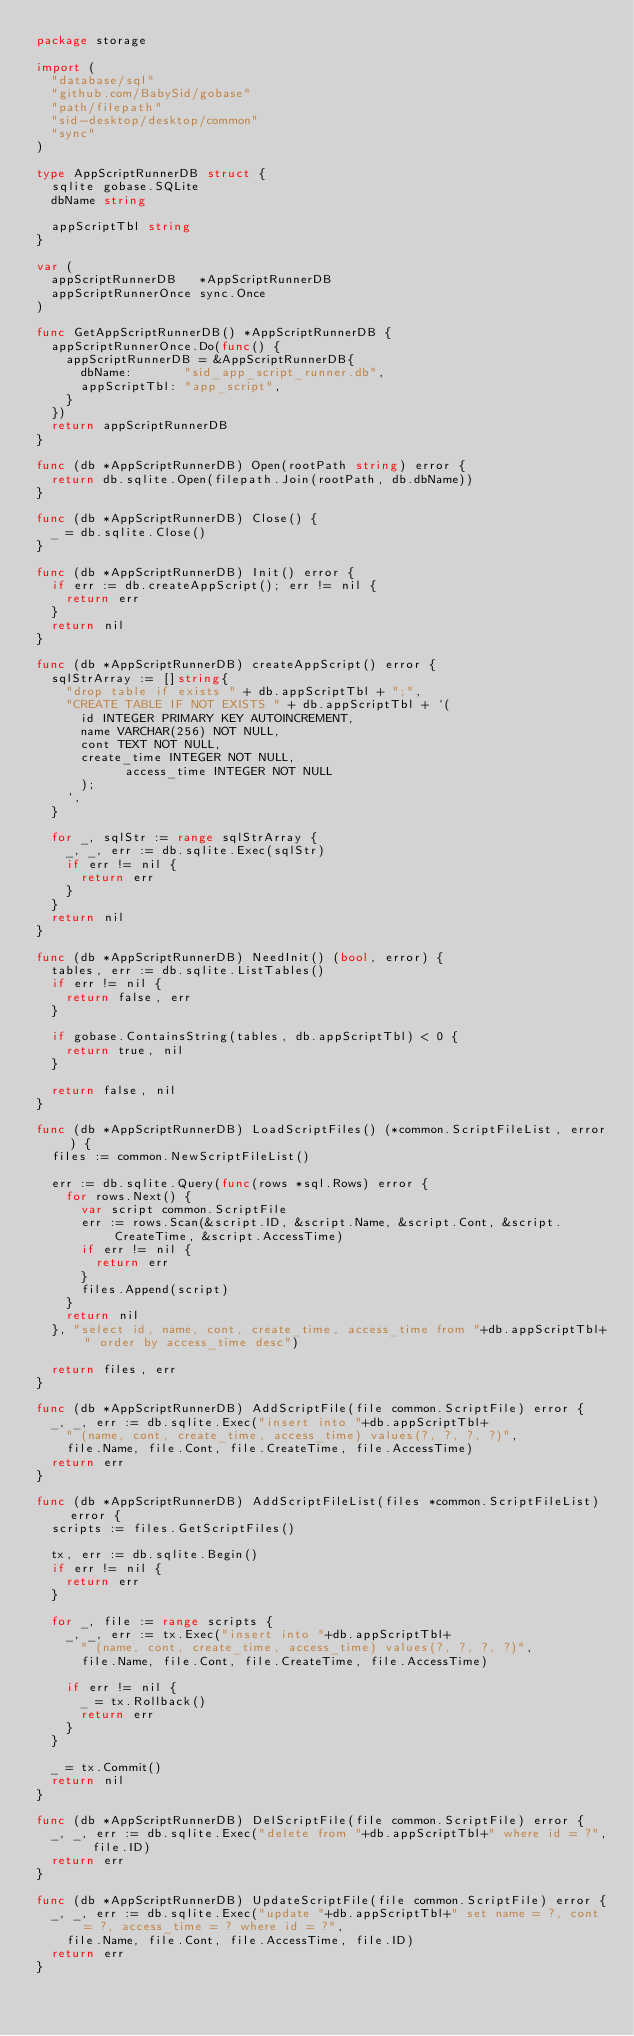<code> <loc_0><loc_0><loc_500><loc_500><_Go_>package storage

import (
	"database/sql"
	"github.com/BabySid/gobase"
	"path/filepath"
	"sid-desktop/desktop/common"
	"sync"
)

type AppScriptRunnerDB struct {
	sqlite gobase.SQLite
	dbName string

	appScriptTbl string
}

var (
	appScriptRunnerDB   *AppScriptRunnerDB
	appScriptRunnerOnce sync.Once
)

func GetAppScriptRunnerDB() *AppScriptRunnerDB {
	appScriptRunnerOnce.Do(func() {
		appScriptRunnerDB = &AppScriptRunnerDB{
			dbName:       "sid_app_script_runner.db",
			appScriptTbl: "app_script",
		}
	})
	return appScriptRunnerDB
}

func (db *AppScriptRunnerDB) Open(rootPath string) error {
	return db.sqlite.Open(filepath.Join(rootPath, db.dbName))
}

func (db *AppScriptRunnerDB) Close() {
	_ = db.sqlite.Close()
}

func (db *AppScriptRunnerDB) Init() error {
	if err := db.createAppScript(); err != nil {
		return err
	}
	return nil
}

func (db *AppScriptRunnerDB) createAppScript() error {
	sqlStrArray := []string{
		"drop table if exists " + db.appScriptTbl + ";",
		"CREATE TABLE IF NOT EXISTS " + db.appScriptTbl + `(
			id INTEGER PRIMARY KEY AUTOINCREMENT,
			name VARCHAR(256) NOT NULL,
			cont TEXT NOT NULL,
			create_time INTEGER NOT NULL,
            access_time INTEGER NOT NULL
    	);
		`,
	}

	for _, sqlStr := range sqlStrArray {
		_, _, err := db.sqlite.Exec(sqlStr)
		if err != nil {
			return err
		}
	}
	return nil
}

func (db *AppScriptRunnerDB) NeedInit() (bool, error) {
	tables, err := db.sqlite.ListTables()
	if err != nil {
		return false, err
	}

	if gobase.ContainsString(tables, db.appScriptTbl) < 0 {
		return true, nil
	}

	return false, nil
}

func (db *AppScriptRunnerDB) LoadScriptFiles() (*common.ScriptFileList, error) {
	files := common.NewScriptFileList()

	err := db.sqlite.Query(func(rows *sql.Rows) error {
		for rows.Next() {
			var script common.ScriptFile
			err := rows.Scan(&script.ID, &script.Name, &script.Cont, &script.CreateTime, &script.AccessTime)
			if err != nil {
				return err
			}
			files.Append(script)
		}
		return nil
	}, "select id, name, cont, create_time, access_time from "+db.appScriptTbl+" order by access_time desc")

	return files, err
}

func (db *AppScriptRunnerDB) AddScriptFile(file common.ScriptFile) error {
	_, _, err := db.sqlite.Exec("insert into "+db.appScriptTbl+
		" (name, cont, create_time, access_time) values(?, ?, ?, ?)",
		file.Name, file.Cont, file.CreateTime, file.AccessTime)
	return err
}

func (db *AppScriptRunnerDB) AddScriptFileList(files *common.ScriptFileList) error {
	scripts := files.GetScriptFiles()

	tx, err := db.sqlite.Begin()
	if err != nil {
		return err
	}

	for _, file := range scripts {
		_, _, err := tx.Exec("insert into "+db.appScriptTbl+
			" (name, cont, create_time, access_time) values(?, ?, ?, ?)",
			file.Name, file.Cont, file.CreateTime, file.AccessTime)

		if err != nil {
			_ = tx.Rollback()
			return err
		}
	}

	_ = tx.Commit()
	return nil
}

func (db *AppScriptRunnerDB) DelScriptFile(file common.ScriptFile) error {
	_, _, err := db.sqlite.Exec("delete from "+db.appScriptTbl+" where id = ?", file.ID)
	return err
}

func (db *AppScriptRunnerDB) UpdateScriptFile(file common.ScriptFile) error {
	_, _, err := db.sqlite.Exec("update "+db.appScriptTbl+" set name = ?, cont = ?, access_time = ? where id = ?",
		file.Name, file.Cont, file.AccessTime, file.ID)
	return err
}
</code> 